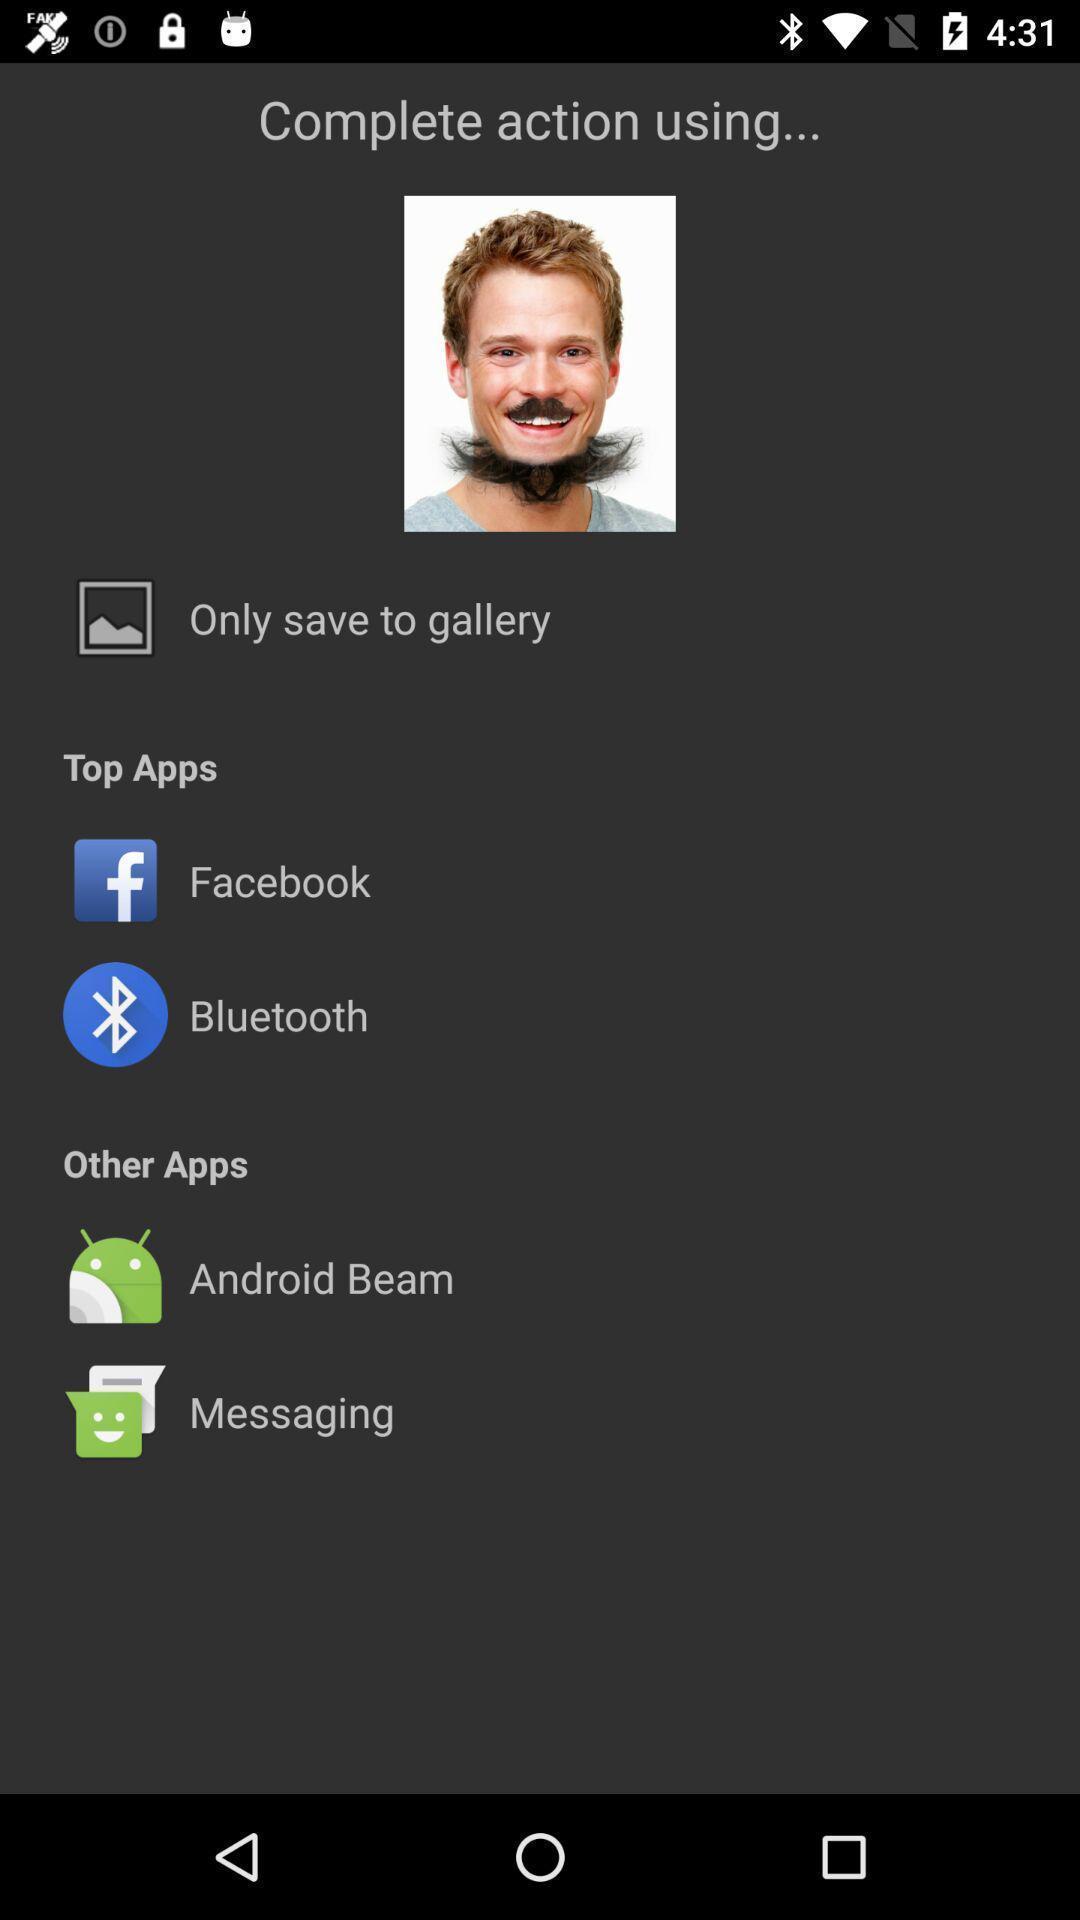Summarize the main components in this picture. Screen shows to complete action using multiple apps. 